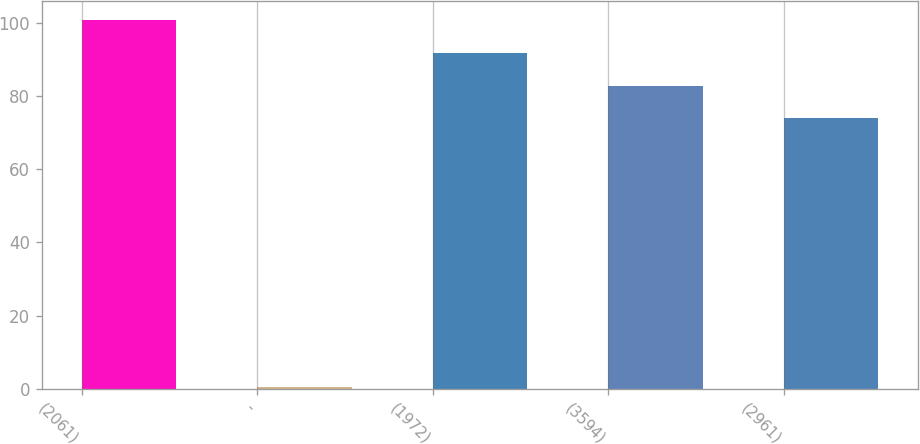Convert chart. <chart><loc_0><loc_0><loc_500><loc_500><bar_chart><fcel>(2061)<fcel>-<fcel>(1972)<fcel>(3594)<fcel>(2961)<nl><fcel>100.84<fcel>0.5<fcel>91.86<fcel>82.88<fcel>73.9<nl></chart> 